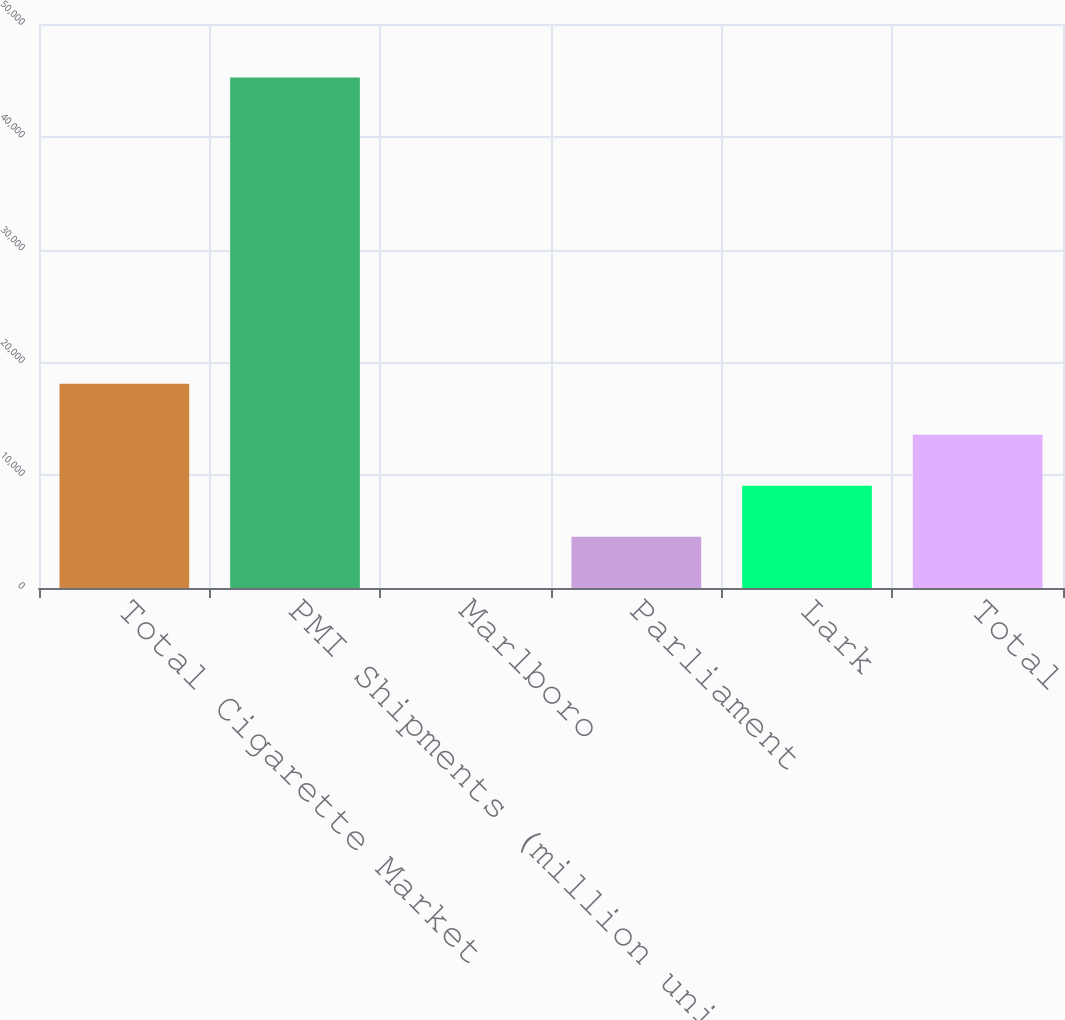Convert chart to OTSL. <chart><loc_0><loc_0><loc_500><loc_500><bar_chart><fcel>Total Cigarette Market<fcel>PMI Shipments (million units)<fcel>Marlboro<fcel>Parliament<fcel>Lark<fcel>Total<nl><fcel>18104.1<fcel>45247<fcel>8.9<fcel>4532.71<fcel>9056.52<fcel>13580.3<nl></chart> 